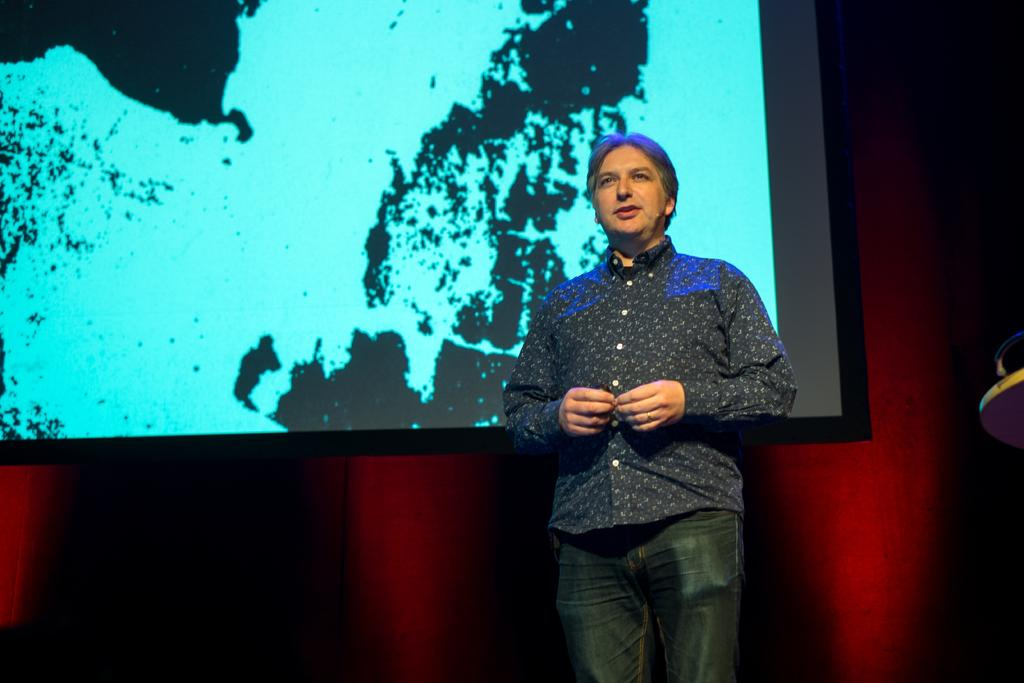What is the main subject of the image? There is a person standing in the image. Can you describe the background of the image? There is a screen attached to the wall in the background of the image. What type of punishment is the person receiving in the image? There is no indication of punishment in the image; it simply shows a person standing with a screen in the background. 